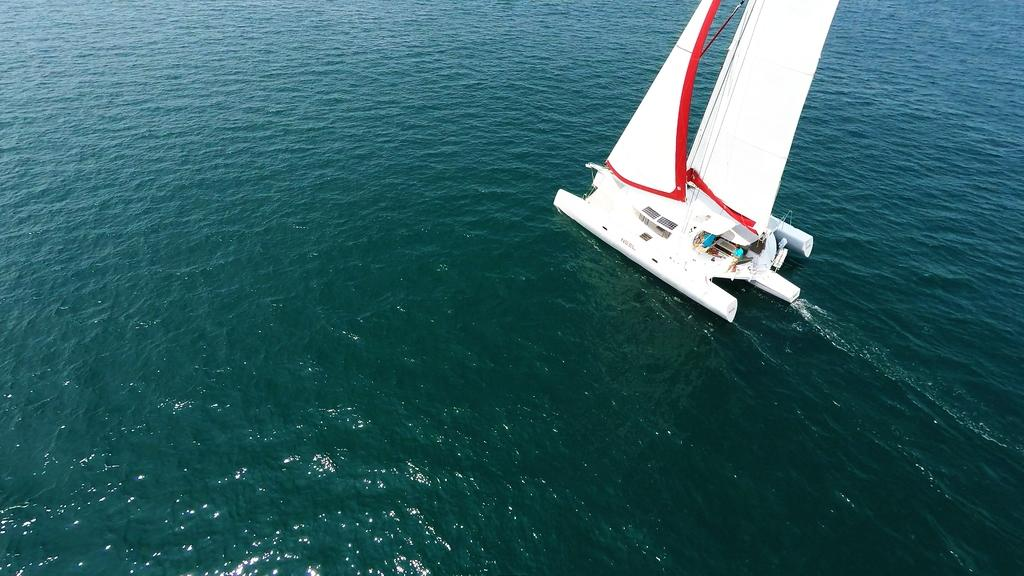Who is present in the image? There are people in the image. What are the people doing in the image? The people are sailing a boat. Where is the boat located in the image? The boat is on the water. What type of snails can be seen on the boat in the image? There are no snails present in the image; it features people sailing a boat on the water. What is the boat using to navigate through the snow in the image? There is no snow present in the image, and the boat is not navigating through any snow. 